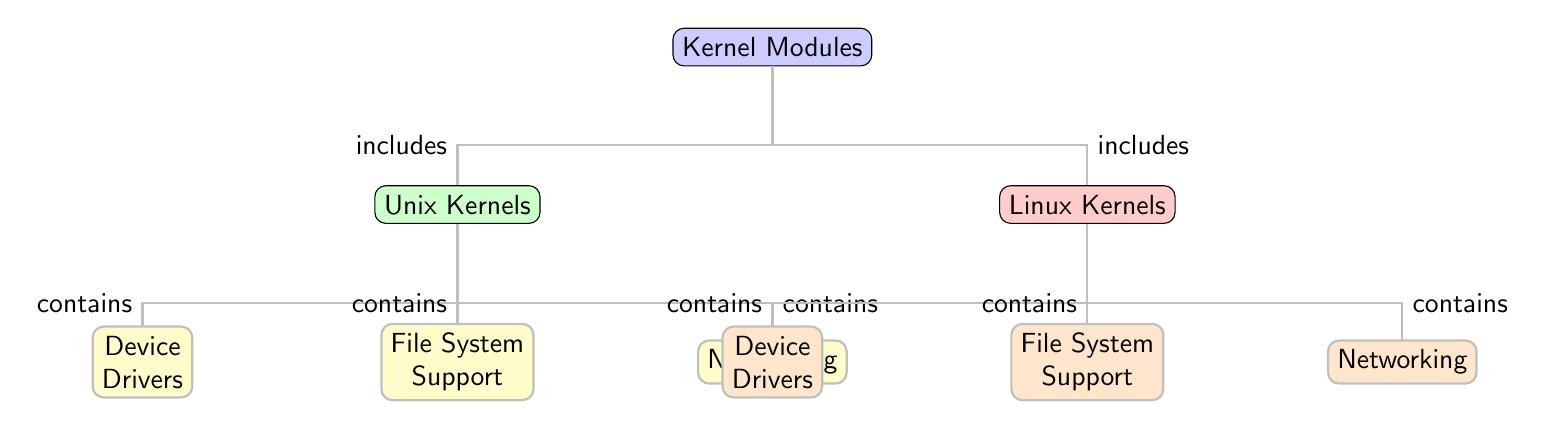What are the two main categories of kernel modules in the diagram? The diagram distinguishes between two main categories of kernel modules: "Unix Kernels" and "Linux Kernels." These are the top-level nodes under the main "Kernel Modules" node.
Answer: Unix Kernels, Linux Kernels How many components are there under Unix Kernels? Under "Unix Kernels," there are three distinct components represented: "Device Drivers," "File System Support," and "Networking." These are the child nodes stemming from the Unix Kernels node.
Answer: 3 What component is shared between Unix and Linux kernels? Both "Unix Kernels" and "Linux Kernels" include a component called "Device Drivers," which is represented as a similar child node under each parent category.
Answer: Device Drivers Which child node is associated with networking in Linux Kernels? In the "Linux Kernels" section, "Networking" is the child node specifically related to networking functionality identified in the diagram.
Answer: Networking How does the diagram illustrate the relationship between Kernel Modules and its types? The diagram clearly shows that "Kernel Modules" is the parent node, from which it branches into two main child categories: "Unix Kernels" and "Linux Kernels," each further containing their respective components. This hierarchical representation establishes the relationship between the general concept of kernel modules and its specific implementations.
Answer: Includes Which category contains more child components, Unix Kernels or Linux Kernels? Both "Unix Kernels" and "Linux Kernels" have an equal number of child components, with each category containing three components. Thus, there is no single category that contains more.
Answer: Neither, they are equal What colors are used for the child modules of Unix and Linux kernels? In the diagram, the child modules of "Unix Kernels" are shown in yellow for "Device Drivers," "File System Support," and "Networking." For "Linux Kernels," the child components are depicted in orange for the same categories.
Answer: Yellow, Orange What does the edge description "contains" signify in the diagram? The edge description "contains" indicates that each of the colored child nodes is a crucial part or component of the respective parent category, whether Unix or Linux Kernel. This relationship denotes the structural composition of each kernel type outlined in the diagram.
Answer: Contains 